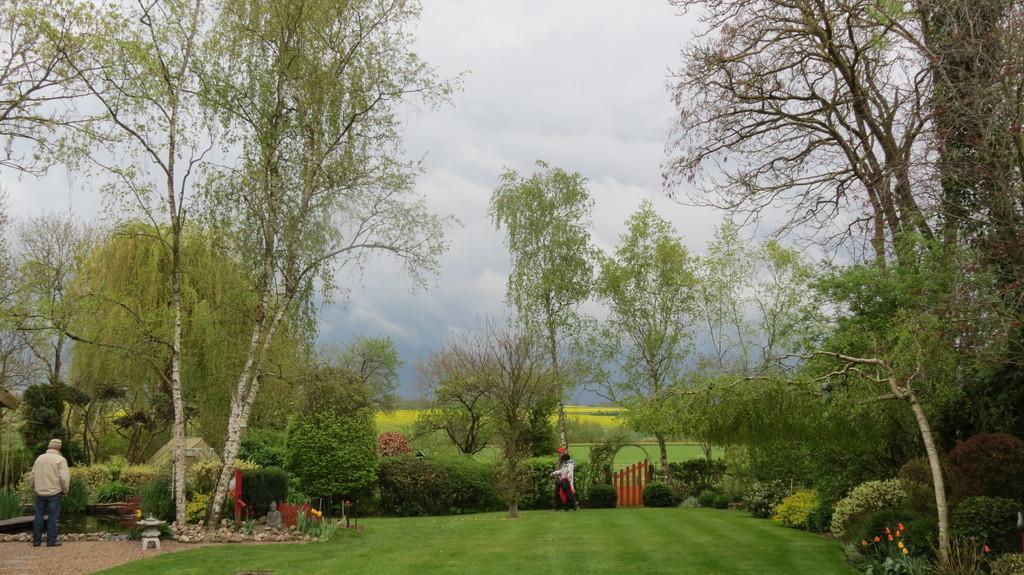How would you summarize this image in a sentence or two? This image consists of many trees and plants. At the bottom, there is green grass. In the image, we can see two persons. On the left, there is a man wearing a brown jacket. In the middle, we can see a gate. At the top, there are clouds in the sky. 